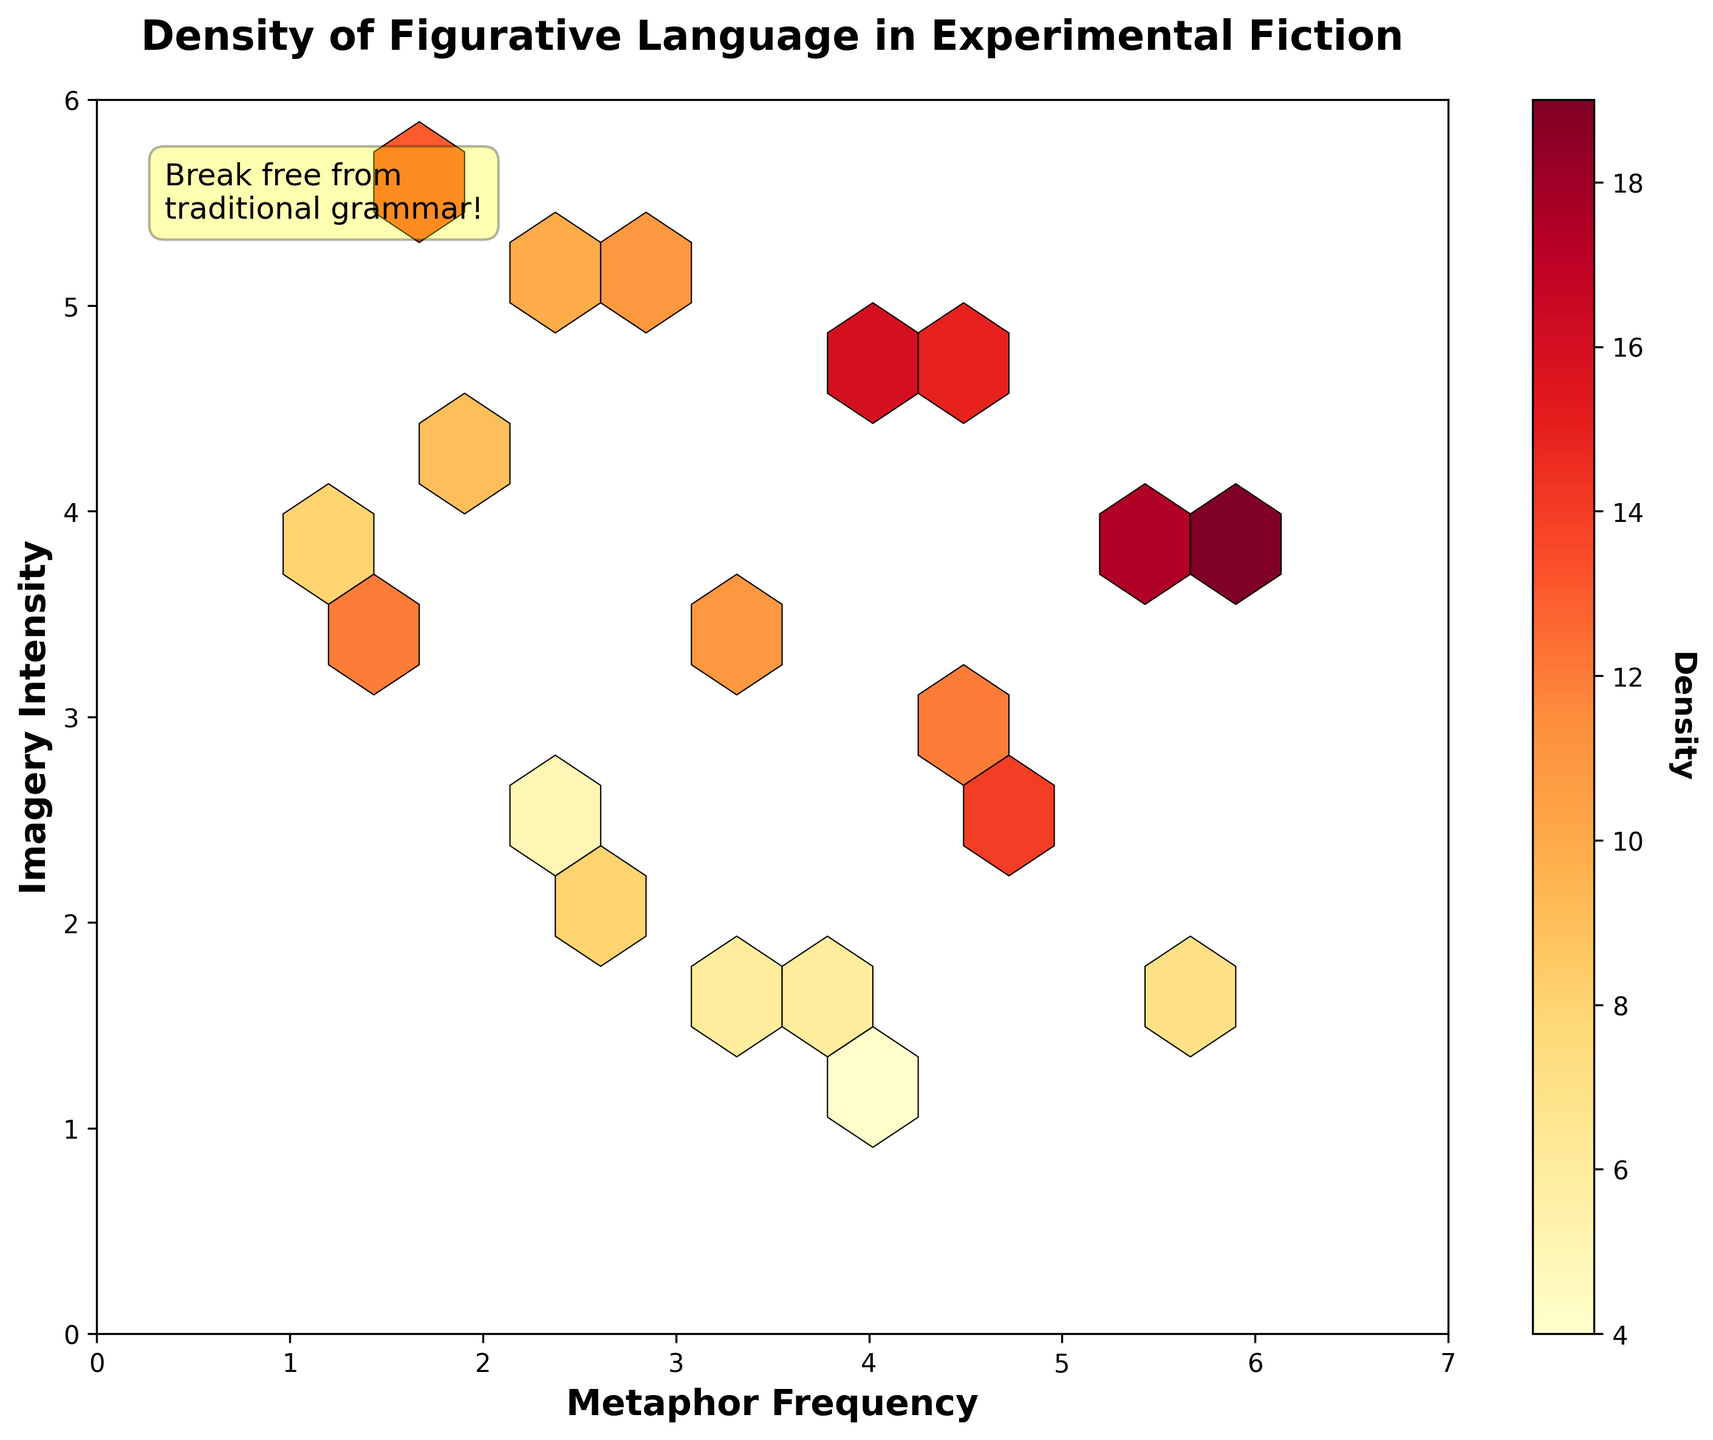What is the title of the plot? The title is shown at the top center of the plot. It reads 'Density of Figurative Language in Experimental Fiction'.
Answer: Density of Figurative Language in Experimental Fiction What do the x and y axes represent? The x-axis label reads 'Metaphor Frequency', and the y-axis label reads 'Imagery Intensity'. These labels indicate what each axis represents.
Answer: Metaphor Frequency and Imagery Intensity How many data points have a density greater than 10? To answer this, we identify hexagons where the density is greater than 10. By checking the density values in the hexagons, we find that 8 data points meet this criteria.
Answer: 8 Which hexagon has the highest density? The highest density is represented by the darkest shade of the color on the color bar. By comparing the colors in the hexagons to the color bar, the hexagon at roughly (6,4) has the highest density of 19.
Answer: (6,4) Is there a hexagon with a density of exactly 15? Scanning the color shades and using their corresponding density values in the color bar, we find a hexagon with density 15 around the (4.5,4.7) mark.
Answer: Yes, around (4.5,4.7) What is the color scale used for representing density? The color bar on the right side of the plot indicates the color scale used. It ranges from light to dark yellow-orange-red shades, as represented by the 'YlOrRd' colormap.
Answer: Yellows and reds Which axis has more influence in the highest density area? By examining the highest density area at (6,4), and seeing other high-density points, we notice higher density clusters around higher values of the x-axis.
Answer: Metaphor Frequency (x-axis) What can be interpreted from the area with the highest density? The highest density around (6,4) suggests that in these experimental fiction works, areas with the highest metaphor frequency also tend to have high imagery intensity.
Answer: High metaphor frequency relates to high imagery intensity How does the density vary between the middle and top right sections of the plot? Comparing the middle (centered around 3,3.5) and the top right (around 6,4) areas, the top right section has higher density based on the darker shades.
Answer: Higher in the top right Where is the annotation placed in the plot? The annotation "Break free from traditional grammar!" is found at the top left corner within the plot area.
Answer: Top left corner 